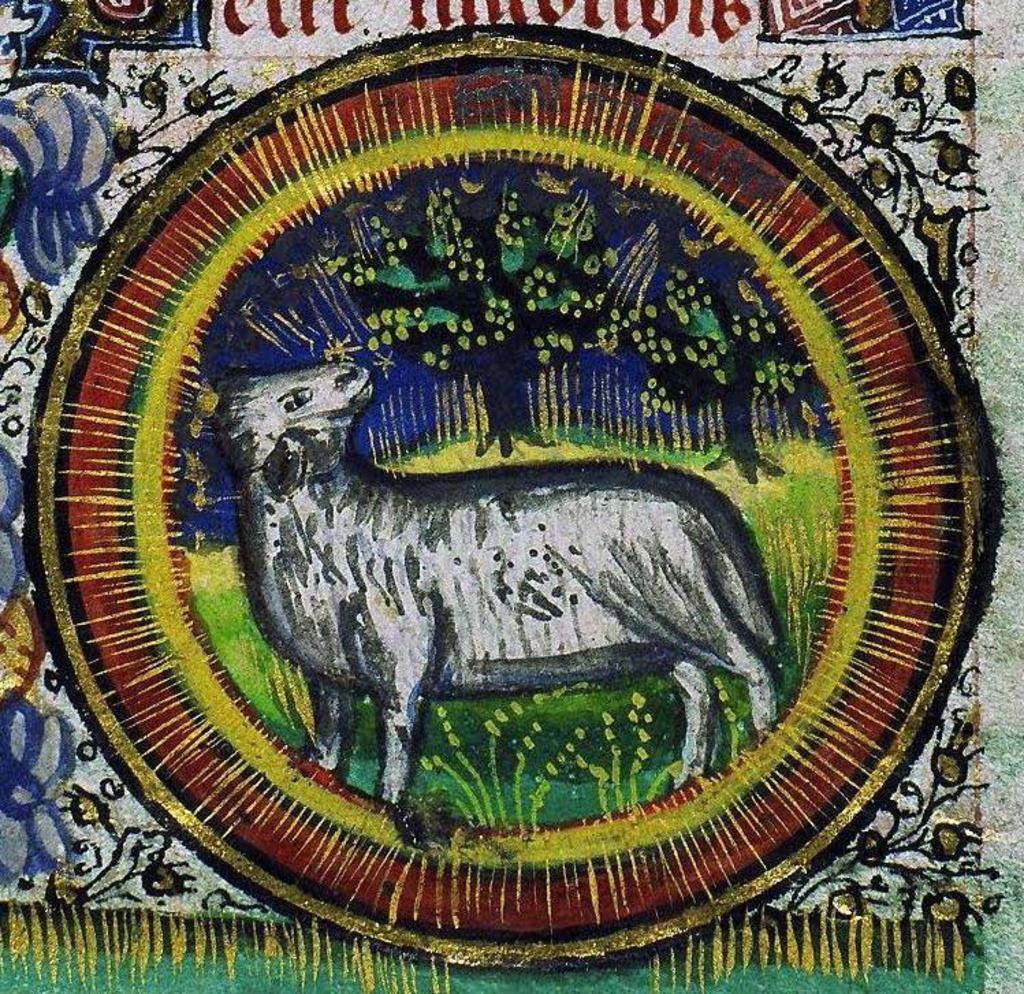How would you summarize this image in a sentence or two? In the image we can see there is a painting, in the painting we can see an animal, grass and tree. 